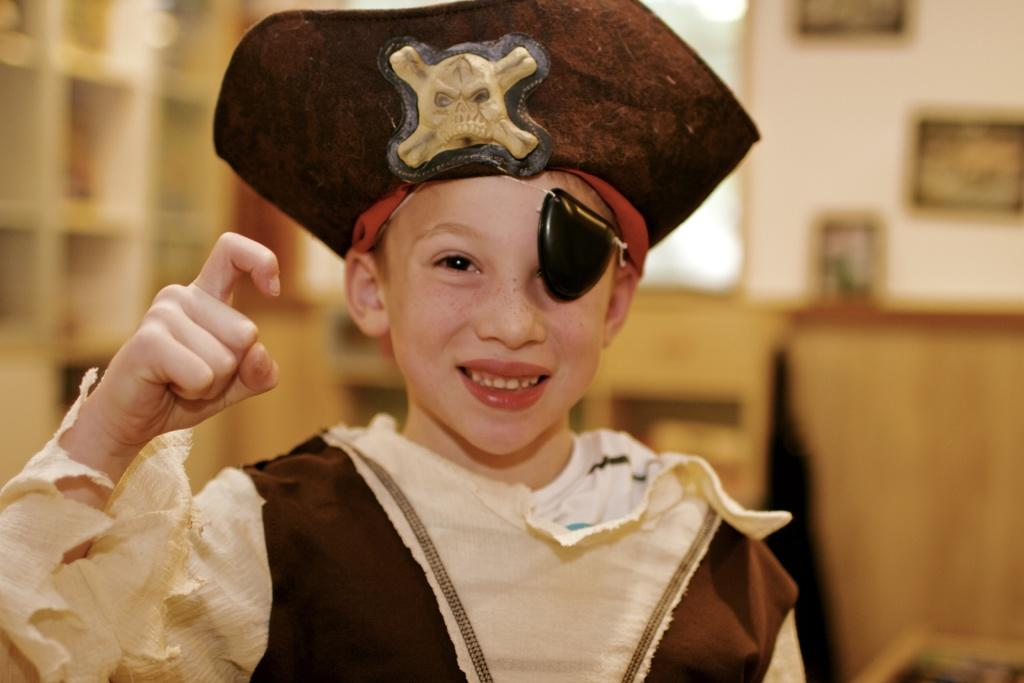Who is the main subject in the image? There is a boy in the image. What is the boy wearing? The boy is wearing a costume. What can be seen in the background of the image? There are shelves, photo frames, and other objects visible in the background. Is the boy playing with a sheet of water in the image? There is no sheet of water present in the image, and the boy is not interacting with any water. 